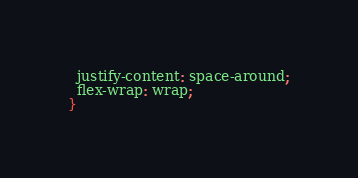Convert code to text. <code><loc_0><loc_0><loc_500><loc_500><_CSS_>  justify-content: space-around;
  flex-wrap: wrap;
}
</code> 